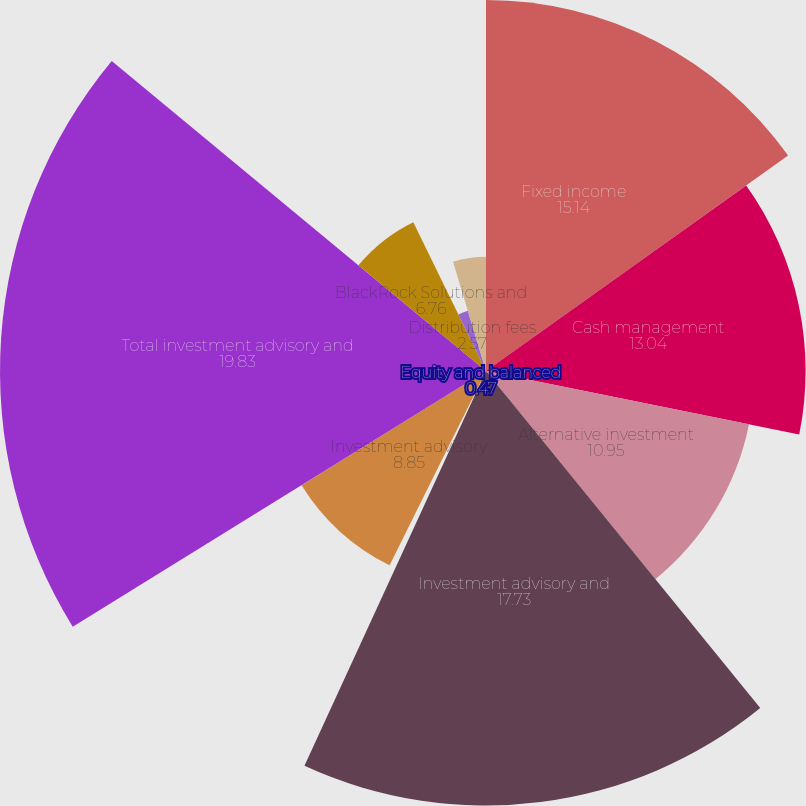Convert chart. <chart><loc_0><loc_0><loc_500><loc_500><pie_chart><fcel>Fixed income<fcel>Cash management<fcel>Alternative investment<fcel>Investment advisory and<fcel>Equity and balanced<fcel>Investment advisory<fcel>Total investment advisory and<fcel>BlackRock Solutions and<fcel>Distribution fees<fcel>Other revenue<nl><fcel>15.14%<fcel>13.04%<fcel>10.95%<fcel>17.73%<fcel>0.47%<fcel>8.85%<fcel>19.83%<fcel>6.76%<fcel>2.57%<fcel>4.66%<nl></chart> 